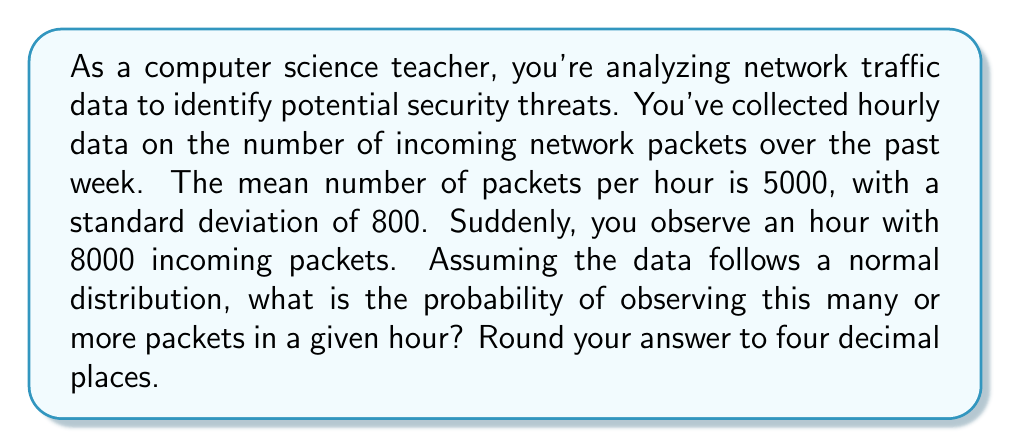Show me your answer to this math problem. To solve this problem, we'll use the concept of z-scores and the standard normal distribution.

1. Calculate the z-score:
   The z-score tells us how many standard deviations an observation is from the mean.
   
   $$z = \frac{x - \mu}{\sigma}$$
   
   where:
   $x$ = observed value (8000 packets)
   $\mu$ = mean (5000 packets)
   $\sigma$ = standard deviation (800 packets)

   $$z = \frac{8000 - 5000}{800} = \frac{3000}{800} = 3.75$$

2. Find the probability:
   We want to find P(X ≥ 8000), which is equivalent to P(Z ≥ 3.75) in the standard normal distribution.

3. Use the standard normal table or a calculator to find the area to the right of z = 3.75.
   This area represents the probability of observing a value this extreme or more extreme.

4. Most tables give the area to the left, so we'll subtract from 1:
   P(Z ≥ 3.75) = 1 - P(Z < 3.75)
   
   Using a standard normal table or calculator, we find:
   P(Z < 3.75) ≈ 0.99991

   Therefore, P(Z ≥ 3.75) = 1 - 0.99991 ≈ 0.00009

5. Rounding to four decimal places, we get 0.0001.

This extremely low probability suggests that observing 8000 or more packets in an hour is highly unusual and could indicate a potential security threat, such as a Distributed Denial of Service (DDoS) attack.
Answer: 0.0001 